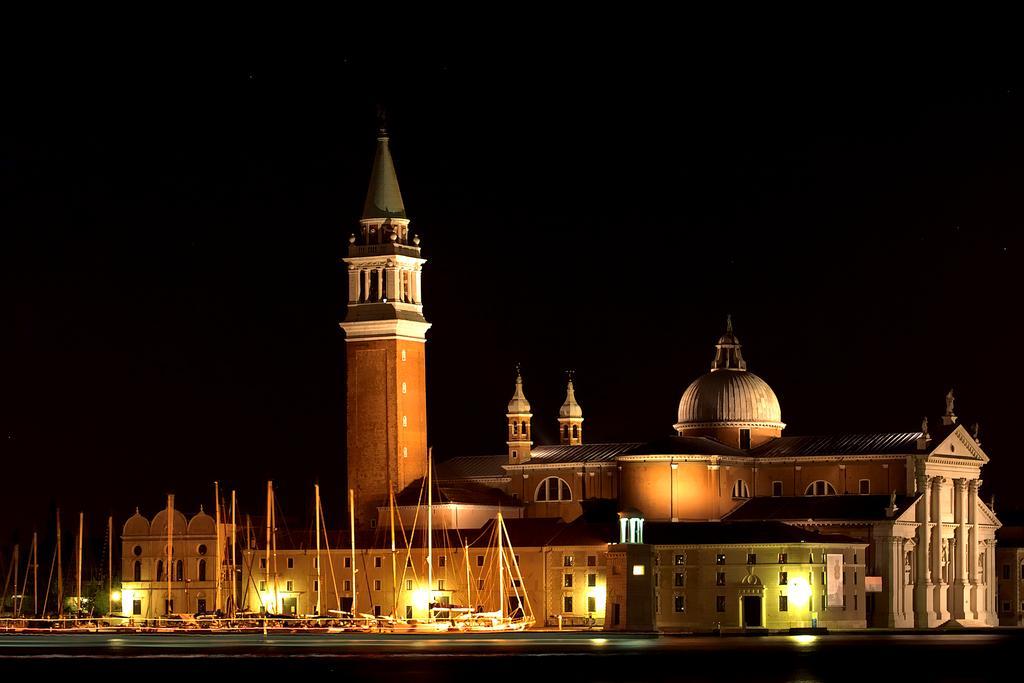Please provide a concise description of this image. In this picture we can see few buildings, lights and trees, and also we can see few boats. 